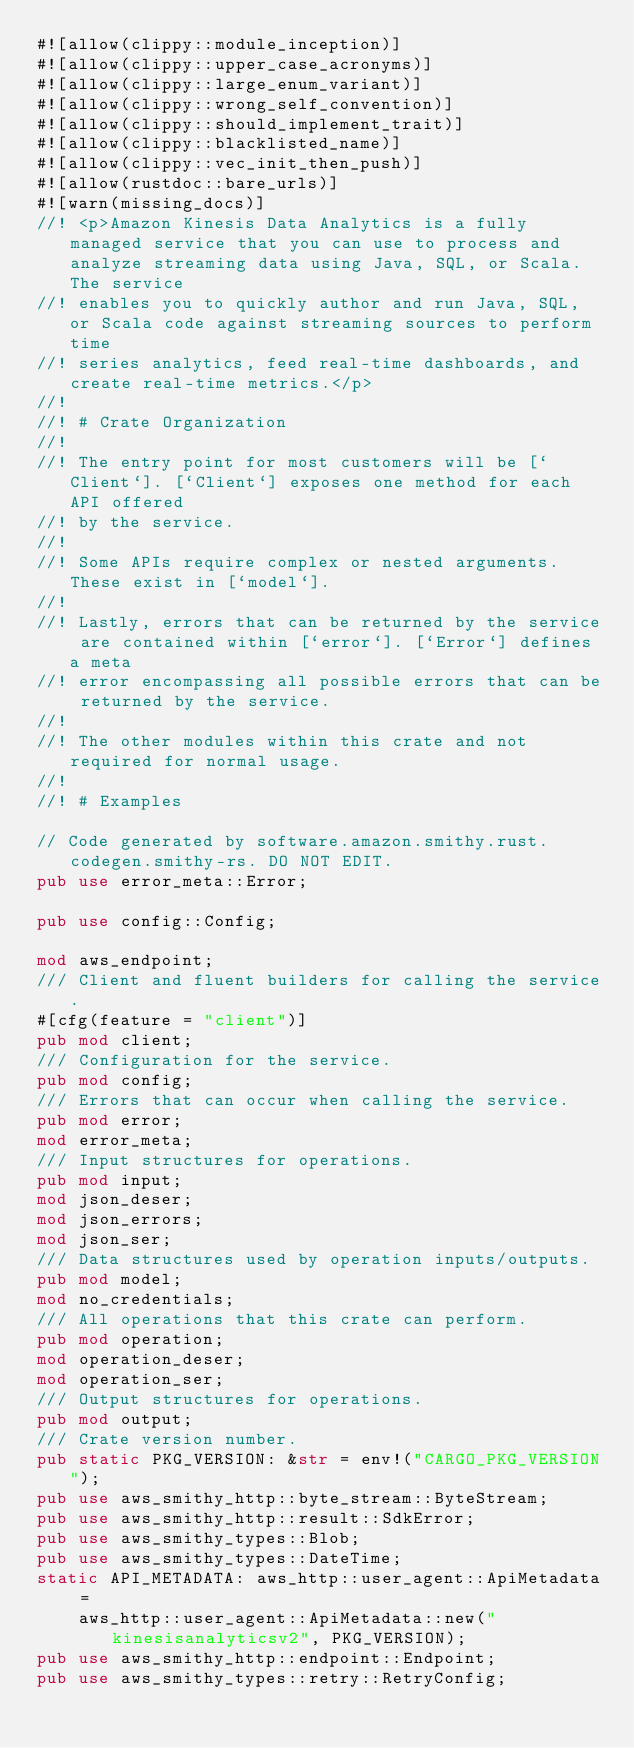<code> <loc_0><loc_0><loc_500><loc_500><_Rust_>#![allow(clippy::module_inception)]
#![allow(clippy::upper_case_acronyms)]
#![allow(clippy::large_enum_variant)]
#![allow(clippy::wrong_self_convention)]
#![allow(clippy::should_implement_trait)]
#![allow(clippy::blacklisted_name)]
#![allow(clippy::vec_init_then_push)]
#![allow(rustdoc::bare_urls)]
#![warn(missing_docs)]
//! <p>Amazon Kinesis Data Analytics is a fully managed service that you can use to process and analyze streaming data using Java, SQL, or Scala. The service
//! enables you to quickly author and run Java, SQL, or Scala code against streaming sources to perform time
//! series analytics, feed real-time dashboards, and create real-time metrics.</p>
//!
//! # Crate Organization
//!
//! The entry point for most customers will be [`Client`]. [`Client`] exposes one method for each API offered
//! by the service.
//!
//! Some APIs require complex or nested arguments. These exist in [`model`].
//!
//! Lastly, errors that can be returned by the service are contained within [`error`]. [`Error`] defines a meta
//! error encompassing all possible errors that can be returned by the service.
//!
//! The other modules within this crate and not required for normal usage.
//!
//! # Examples

// Code generated by software.amazon.smithy.rust.codegen.smithy-rs. DO NOT EDIT.
pub use error_meta::Error;

pub use config::Config;

mod aws_endpoint;
/// Client and fluent builders for calling the service.
#[cfg(feature = "client")]
pub mod client;
/// Configuration for the service.
pub mod config;
/// Errors that can occur when calling the service.
pub mod error;
mod error_meta;
/// Input structures for operations.
pub mod input;
mod json_deser;
mod json_errors;
mod json_ser;
/// Data structures used by operation inputs/outputs.
pub mod model;
mod no_credentials;
/// All operations that this crate can perform.
pub mod operation;
mod operation_deser;
mod operation_ser;
/// Output structures for operations.
pub mod output;
/// Crate version number.
pub static PKG_VERSION: &str = env!("CARGO_PKG_VERSION");
pub use aws_smithy_http::byte_stream::ByteStream;
pub use aws_smithy_http::result::SdkError;
pub use aws_smithy_types::Blob;
pub use aws_smithy_types::DateTime;
static API_METADATA: aws_http::user_agent::ApiMetadata =
    aws_http::user_agent::ApiMetadata::new("kinesisanalyticsv2", PKG_VERSION);
pub use aws_smithy_http::endpoint::Endpoint;
pub use aws_smithy_types::retry::RetryConfig;</code> 